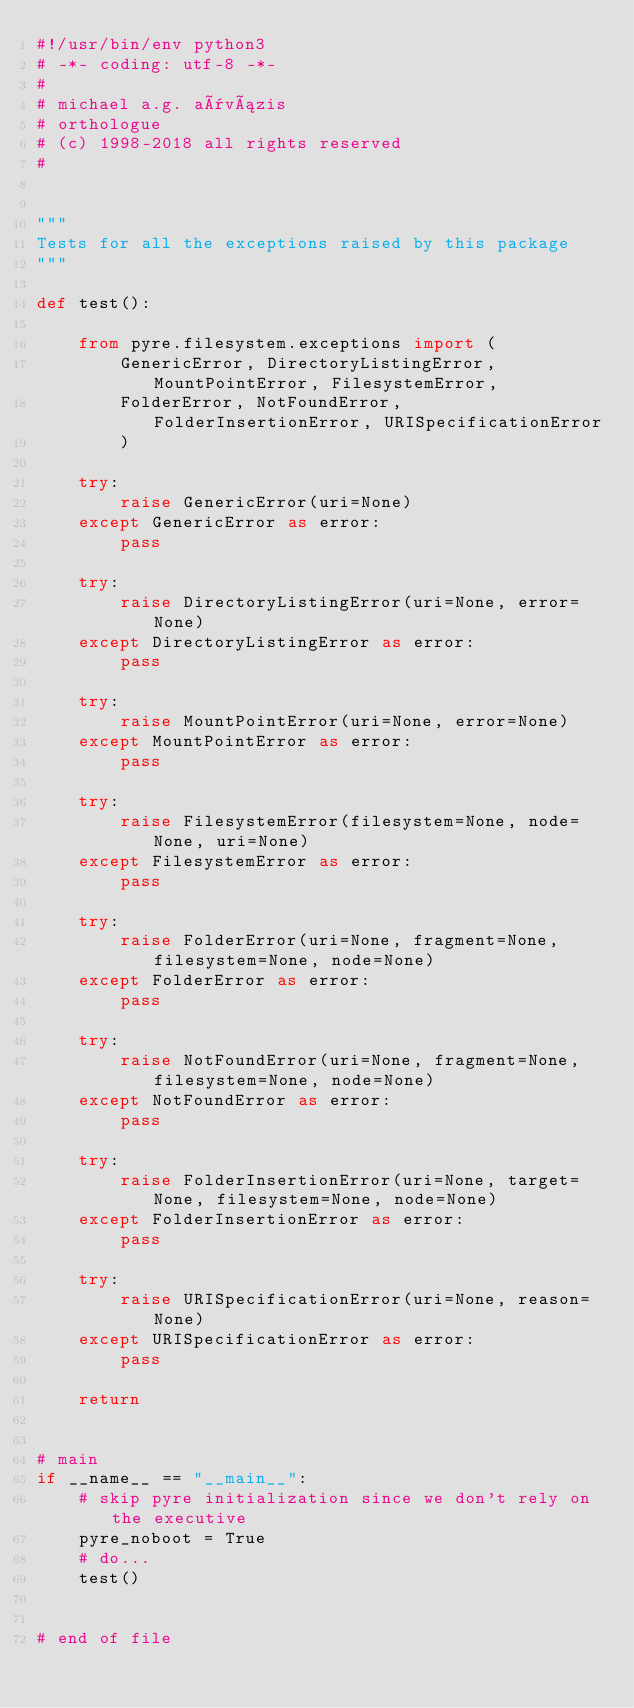<code> <loc_0><loc_0><loc_500><loc_500><_Python_>#!/usr/bin/env python3
# -*- coding: utf-8 -*-
#
# michael a.g. aïvázis
# orthologue
# (c) 1998-2018 all rights reserved
#


"""
Tests for all the exceptions raised by this package
"""

def test():

    from pyre.filesystem.exceptions import (
        GenericError, DirectoryListingError, MountPointError, FilesystemError,
        FolderError, NotFoundError, FolderInsertionError, URISpecificationError
        )

    try:
        raise GenericError(uri=None)
    except GenericError as error:
        pass

    try:
        raise DirectoryListingError(uri=None, error=None)
    except DirectoryListingError as error:
        pass

    try:
        raise MountPointError(uri=None, error=None)
    except MountPointError as error:
        pass

    try:
        raise FilesystemError(filesystem=None, node=None, uri=None)
    except FilesystemError as error:
        pass

    try:
        raise FolderError(uri=None, fragment=None, filesystem=None, node=None)
    except FolderError as error:
        pass

    try:
        raise NotFoundError(uri=None, fragment=None, filesystem=None, node=None)
    except NotFoundError as error:
        pass

    try:
        raise FolderInsertionError(uri=None, target=None, filesystem=None, node=None)
    except FolderInsertionError as error:
        pass

    try:
        raise URISpecificationError(uri=None, reason=None)
    except URISpecificationError as error:
        pass

    return


# main
if __name__ == "__main__":
    # skip pyre initialization since we don't rely on the executive
    pyre_noboot = True
    # do...
    test()


# end of file
</code> 